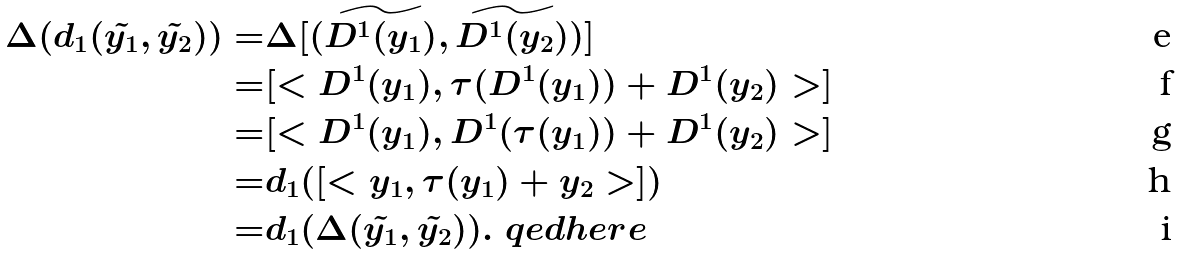<formula> <loc_0><loc_0><loc_500><loc_500>\Delta ( d _ { 1 } ( \tilde { y _ { 1 } } , \tilde { y _ { 2 } } ) ) = & \Delta [ ( \widetilde { D ^ { 1 } ( y _ { 1 } ) } , \widetilde { D ^ { 1 } ( y _ { 2 } ) } ) ] \\ = & [ < D ^ { 1 } ( y _ { 1 } ) , \tau ( D ^ { 1 } ( y _ { 1 } ) ) + D ^ { 1 } ( y _ { 2 } ) > ] \\ = & [ < D ^ { 1 } ( y _ { 1 } ) , D ^ { 1 } ( \tau ( y _ { 1 } ) ) + D ^ { 1 } ( y _ { 2 } ) > ] \\ = & d _ { 1 } ( [ < y _ { 1 } , \tau ( y _ { 1 } ) + y _ { 2 } > ] ) \\ = & d _ { 1 } ( \Delta ( \tilde { y _ { 1 } } , \tilde { y _ { 2 } } ) ) . \ q e d h e r e</formula> 